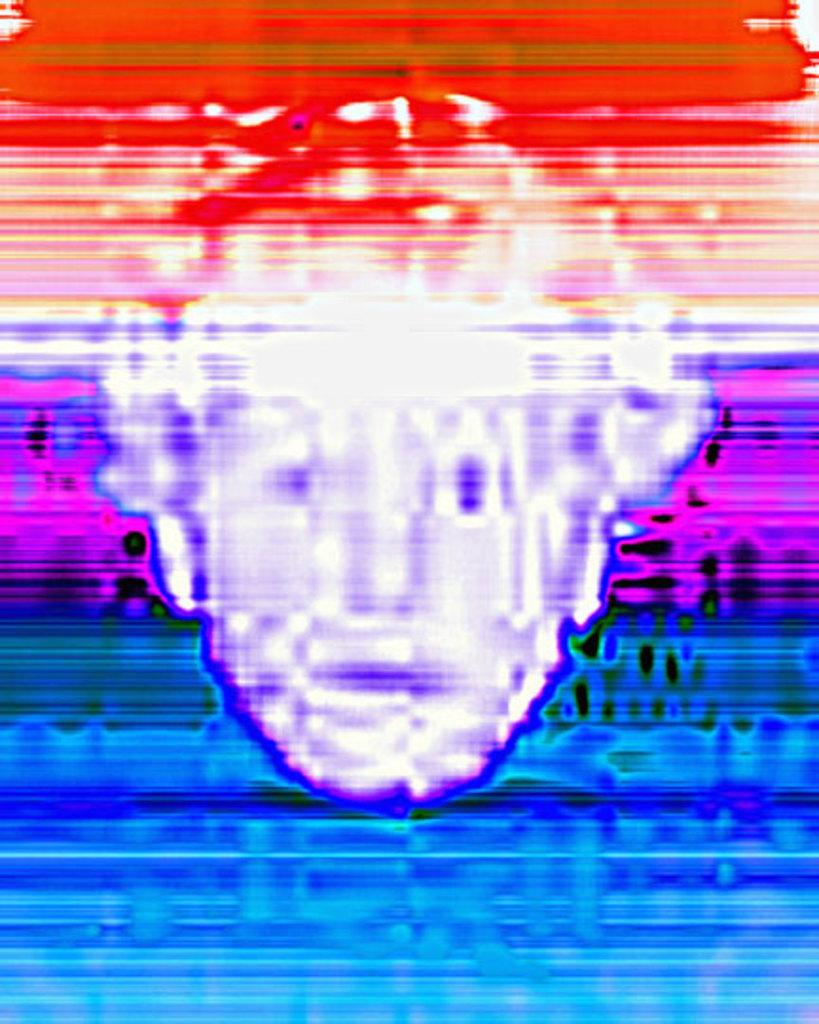What is the main subject of the image? The main subject of the image is a person's face. What type of property can be seen in the background of the image? There is no property visible in the image; the image is a graphic representation of a person's face. 